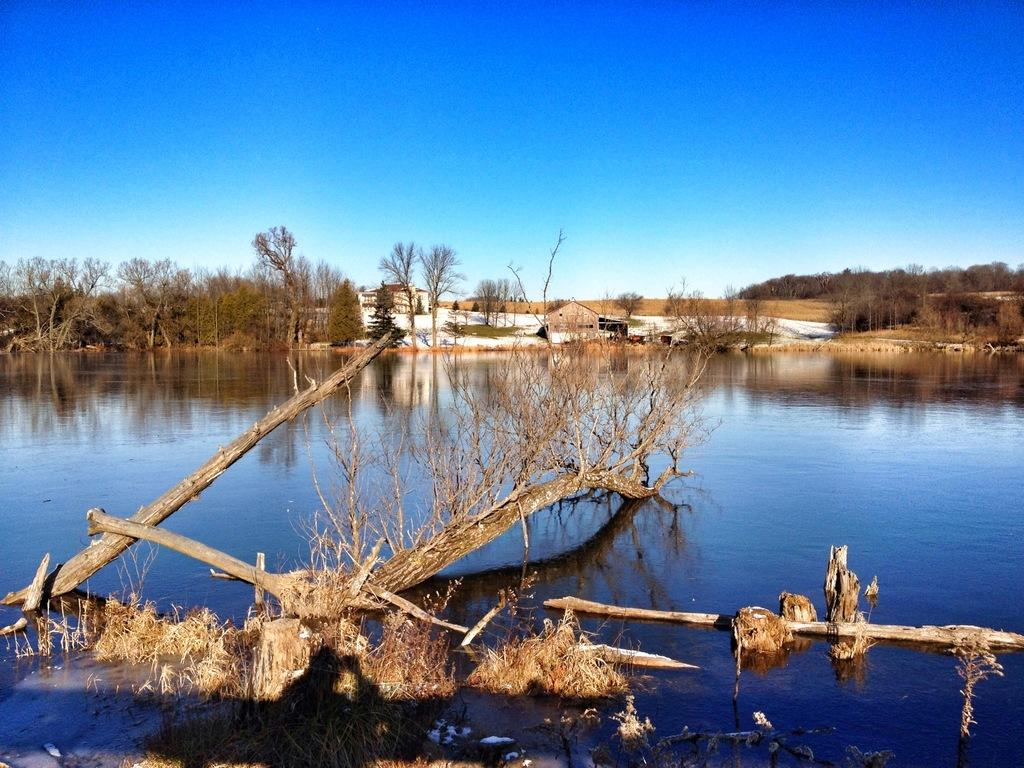What is the main subject in the front of the image? There is a dry tree in the water in the front of the image. What can be seen in the background of the image? There are trees and a building in the background of the image. What is visible in the center of the image? There is water visible in the center of the image. What is the caption of the image? There is no caption present in the image. Is there a girl visible in the image? There is no girl present in the image. 